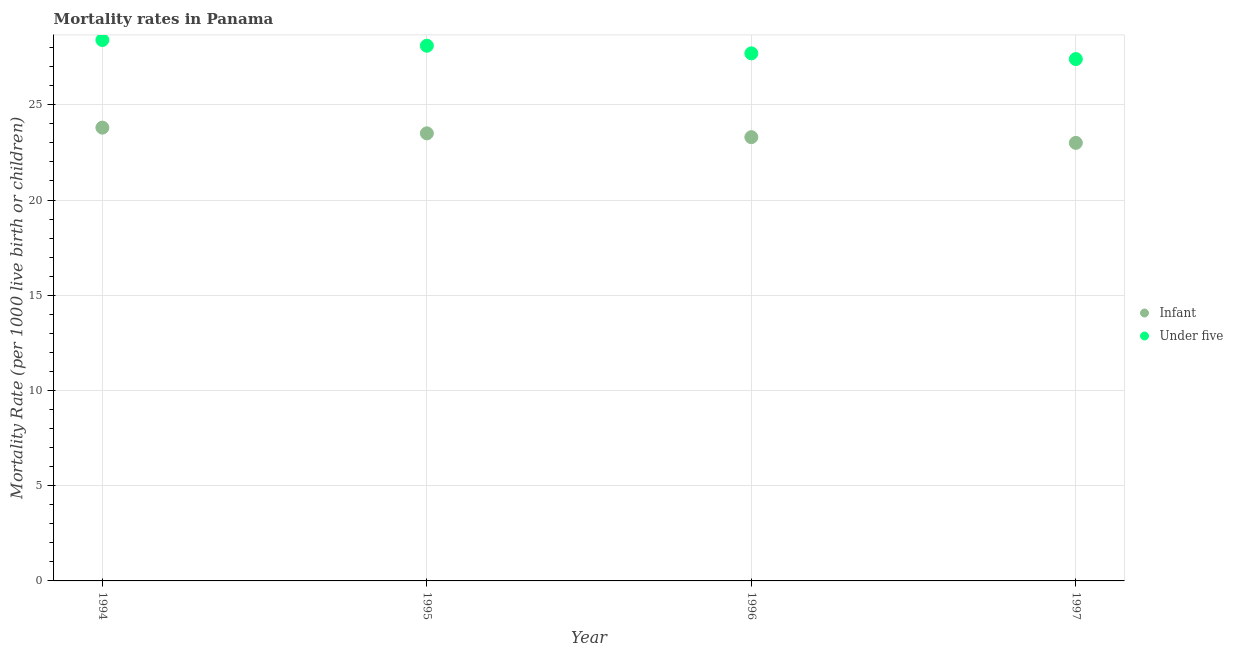How many different coloured dotlines are there?
Ensure brevity in your answer.  2. Is the number of dotlines equal to the number of legend labels?
Provide a succinct answer. Yes. What is the under-5 mortality rate in 1995?
Your answer should be very brief. 28.1. Across all years, what is the maximum under-5 mortality rate?
Offer a terse response. 28.4. Across all years, what is the minimum infant mortality rate?
Give a very brief answer. 23. In which year was the infant mortality rate maximum?
Give a very brief answer. 1994. In which year was the infant mortality rate minimum?
Offer a very short reply. 1997. What is the total infant mortality rate in the graph?
Provide a succinct answer. 93.6. What is the difference between the under-5 mortality rate in 1995 and that in 1997?
Your answer should be very brief. 0.7. What is the difference between the infant mortality rate in 1997 and the under-5 mortality rate in 1995?
Provide a succinct answer. -5.1. What is the average infant mortality rate per year?
Offer a very short reply. 23.4. In the year 1997, what is the difference between the infant mortality rate and under-5 mortality rate?
Your answer should be compact. -4.4. What is the ratio of the infant mortality rate in 1994 to that in 1996?
Give a very brief answer. 1.02. Is the infant mortality rate in 1996 less than that in 1997?
Give a very brief answer. No. What is the difference between the highest and the second highest under-5 mortality rate?
Your answer should be compact. 0.3. Is the sum of the infant mortality rate in 1995 and 1997 greater than the maximum under-5 mortality rate across all years?
Provide a succinct answer. Yes. Does the infant mortality rate monotonically increase over the years?
Provide a short and direct response. No. Is the under-5 mortality rate strictly greater than the infant mortality rate over the years?
Your answer should be compact. Yes. How many dotlines are there?
Give a very brief answer. 2. What is the difference between two consecutive major ticks on the Y-axis?
Offer a very short reply. 5. Are the values on the major ticks of Y-axis written in scientific E-notation?
Give a very brief answer. No. Does the graph contain any zero values?
Offer a terse response. No. How are the legend labels stacked?
Keep it short and to the point. Vertical. What is the title of the graph?
Your answer should be compact. Mortality rates in Panama. Does "Under-5(female)" appear as one of the legend labels in the graph?
Your answer should be very brief. No. What is the label or title of the Y-axis?
Keep it short and to the point. Mortality Rate (per 1000 live birth or children). What is the Mortality Rate (per 1000 live birth or children) in Infant in 1994?
Provide a short and direct response. 23.8. What is the Mortality Rate (per 1000 live birth or children) in Under five in 1994?
Make the answer very short. 28.4. What is the Mortality Rate (per 1000 live birth or children) of Infant in 1995?
Your response must be concise. 23.5. What is the Mortality Rate (per 1000 live birth or children) of Under five in 1995?
Ensure brevity in your answer.  28.1. What is the Mortality Rate (per 1000 live birth or children) in Infant in 1996?
Your answer should be very brief. 23.3. What is the Mortality Rate (per 1000 live birth or children) in Under five in 1996?
Keep it short and to the point. 27.7. What is the Mortality Rate (per 1000 live birth or children) of Under five in 1997?
Your answer should be compact. 27.4. Across all years, what is the maximum Mortality Rate (per 1000 live birth or children) in Infant?
Give a very brief answer. 23.8. Across all years, what is the maximum Mortality Rate (per 1000 live birth or children) of Under five?
Provide a succinct answer. 28.4. Across all years, what is the minimum Mortality Rate (per 1000 live birth or children) of Under five?
Provide a succinct answer. 27.4. What is the total Mortality Rate (per 1000 live birth or children) of Infant in the graph?
Ensure brevity in your answer.  93.6. What is the total Mortality Rate (per 1000 live birth or children) of Under five in the graph?
Keep it short and to the point. 111.6. What is the difference between the Mortality Rate (per 1000 live birth or children) of Infant in 1994 and that in 1995?
Ensure brevity in your answer.  0.3. What is the difference between the Mortality Rate (per 1000 live birth or children) in Infant in 1994 and that in 1996?
Give a very brief answer. 0.5. What is the difference between the Mortality Rate (per 1000 live birth or children) of Under five in 1994 and that in 1996?
Offer a terse response. 0.7. What is the difference between the Mortality Rate (per 1000 live birth or children) in Infant in 1994 and that in 1997?
Provide a short and direct response. 0.8. What is the difference between the Mortality Rate (per 1000 live birth or children) of Infant in 1995 and that in 1996?
Offer a very short reply. 0.2. What is the difference between the Mortality Rate (per 1000 live birth or children) in Under five in 1995 and that in 1996?
Provide a succinct answer. 0.4. What is the difference between the Mortality Rate (per 1000 live birth or children) of Infant in 1995 and that in 1997?
Provide a short and direct response. 0.5. What is the difference between the Mortality Rate (per 1000 live birth or children) of Under five in 1995 and that in 1997?
Make the answer very short. 0.7. What is the difference between the Mortality Rate (per 1000 live birth or children) in Under five in 1996 and that in 1997?
Make the answer very short. 0.3. What is the difference between the Mortality Rate (per 1000 live birth or children) of Infant in 1994 and the Mortality Rate (per 1000 live birth or children) of Under five in 1995?
Provide a succinct answer. -4.3. What is the difference between the Mortality Rate (per 1000 live birth or children) in Infant in 1994 and the Mortality Rate (per 1000 live birth or children) in Under five in 1996?
Offer a terse response. -3.9. What is the difference between the Mortality Rate (per 1000 live birth or children) in Infant in 1994 and the Mortality Rate (per 1000 live birth or children) in Under five in 1997?
Ensure brevity in your answer.  -3.6. What is the difference between the Mortality Rate (per 1000 live birth or children) in Infant in 1996 and the Mortality Rate (per 1000 live birth or children) in Under five in 1997?
Provide a short and direct response. -4.1. What is the average Mortality Rate (per 1000 live birth or children) in Infant per year?
Your answer should be compact. 23.4. What is the average Mortality Rate (per 1000 live birth or children) of Under five per year?
Provide a succinct answer. 27.9. In the year 1995, what is the difference between the Mortality Rate (per 1000 live birth or children) of Infant and Mortality Rate (per 1000 live birth or children) of Under five?
Your answer should be very brief. -4.6. In the year 1996, what is the difference between the Mortality Rate (per 1000 live birth or children) in Infant and Mortality Rate (per 1000 live birth or children) in Under five?
Provide a short and direct response. -4.4. In the year 1997, what is the difference between the Mortality Rate (per 1000 live birth or children) of Infant and Mortality Rate (per 1000 live birth or children) of Under five?
Your response must be concise. -4.4. What is the ratio of the Mortality Rate (per 1000 live birth or children) of Infant in 1994 to that in 1995?
Your response must be concise. 1.01. What is the ratio of the Mortality Rate (per 1000 live birth or children) in Under five in 1994 to that in 1995?
Your answer should be compact. 1.01. What is the ratio of the Mortality Rate (per 1000 live birth or children) of Infant in 1994 to that in 1996?
Keep it short and to the point. 1.02. What is the ratio of the Mortality Rate (per 1000 live birth or children) in Under five in 1994 to that in 1996?
Provide a short and direct response. 1.03. What is the ratio of the Mortality Rate (per 1000 live birth or children) in Infant in 1994 to that in 1997?
Provide a succinct answer. 1.03. What is the ratio of the Mortality Rate (per 1000 live birth or children) in Under five in 1994 to that in 1997?
Provide a short and direct response. 1.04. What is the ratio of the Mortality Rate (per 1000 live birth or children) in Infant in 1995 to that in 1996?
Make the answer very short. 1.01. What is the ratio of the Mortality Rate (per 1000 live birth or children) in Under five in 1995 to that in 1996?
Provide a succinct answer. 1.01. What is the ratio of the Mortality Rate (per 1000 live birth or children) in Infant in 1995 to that in 1997?
Your answer should be compact. 1.02. What is the ratio of the Mortality Rate (per 1000 live birth or children) of Under five in 1995 to that in 1997?
Provide a short and direct response. 1.03. What is the ratio of the Mortality Rate (per 1000 live birth or children) of Infant in 1996 to that in 1997?
Ensure brevity in your answer.  1.01. What is the ratio of the Mortality Rate (per 1000 live birth or children) of Under five in 1996 to that in 1997?
Keep it short and to the point. 1.01. What is the difference between the highest and the second highest Mortality Rate (per 1000 live birth or children) of Infant?
Ensure brevity in your answer.  0.3. 